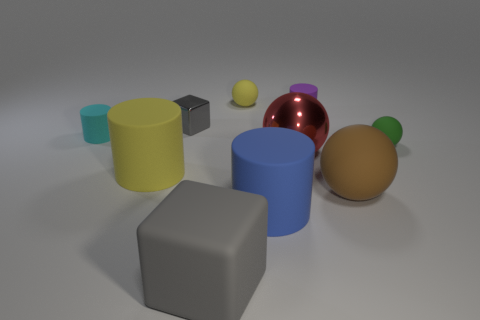Is the big blue cylinder made of the same material as the tiny cylinder that is right of the tiny yellow matte thing?
Ensure brevity in your answer.  Yes. What number of small things are green matte cylinders or red shiny objects?
Your answer should be compact. 0. What material is the small object that is the same color as the large rubber block?
Ensure brevity in your answer.  Metal. Are there fewer green spheres than green cylinders?
Make the answer very short. No. There is a rubber ball in front of the yellow matte cylinder; is its size the same as the matte sphere that is behind the tiny purple cylinder?
Keep it short and to the point. No. What number of yellow things are either small rubber things or tiny cylinders?
Your response must be concise. 1. There is a rubber block that is the same color as the tiny metal cube; what is its size?
Make the answer very short. Large. Are there more big gray matte blocks than cylinders?
Your answer should be very brief. No. Is the large cube the same color as the small metallic cube?
Offer a very short reply. Yes. How many things are big rubber blocks or rubber cylinders behind the large brown object?
Offer a very short reply. 4. 